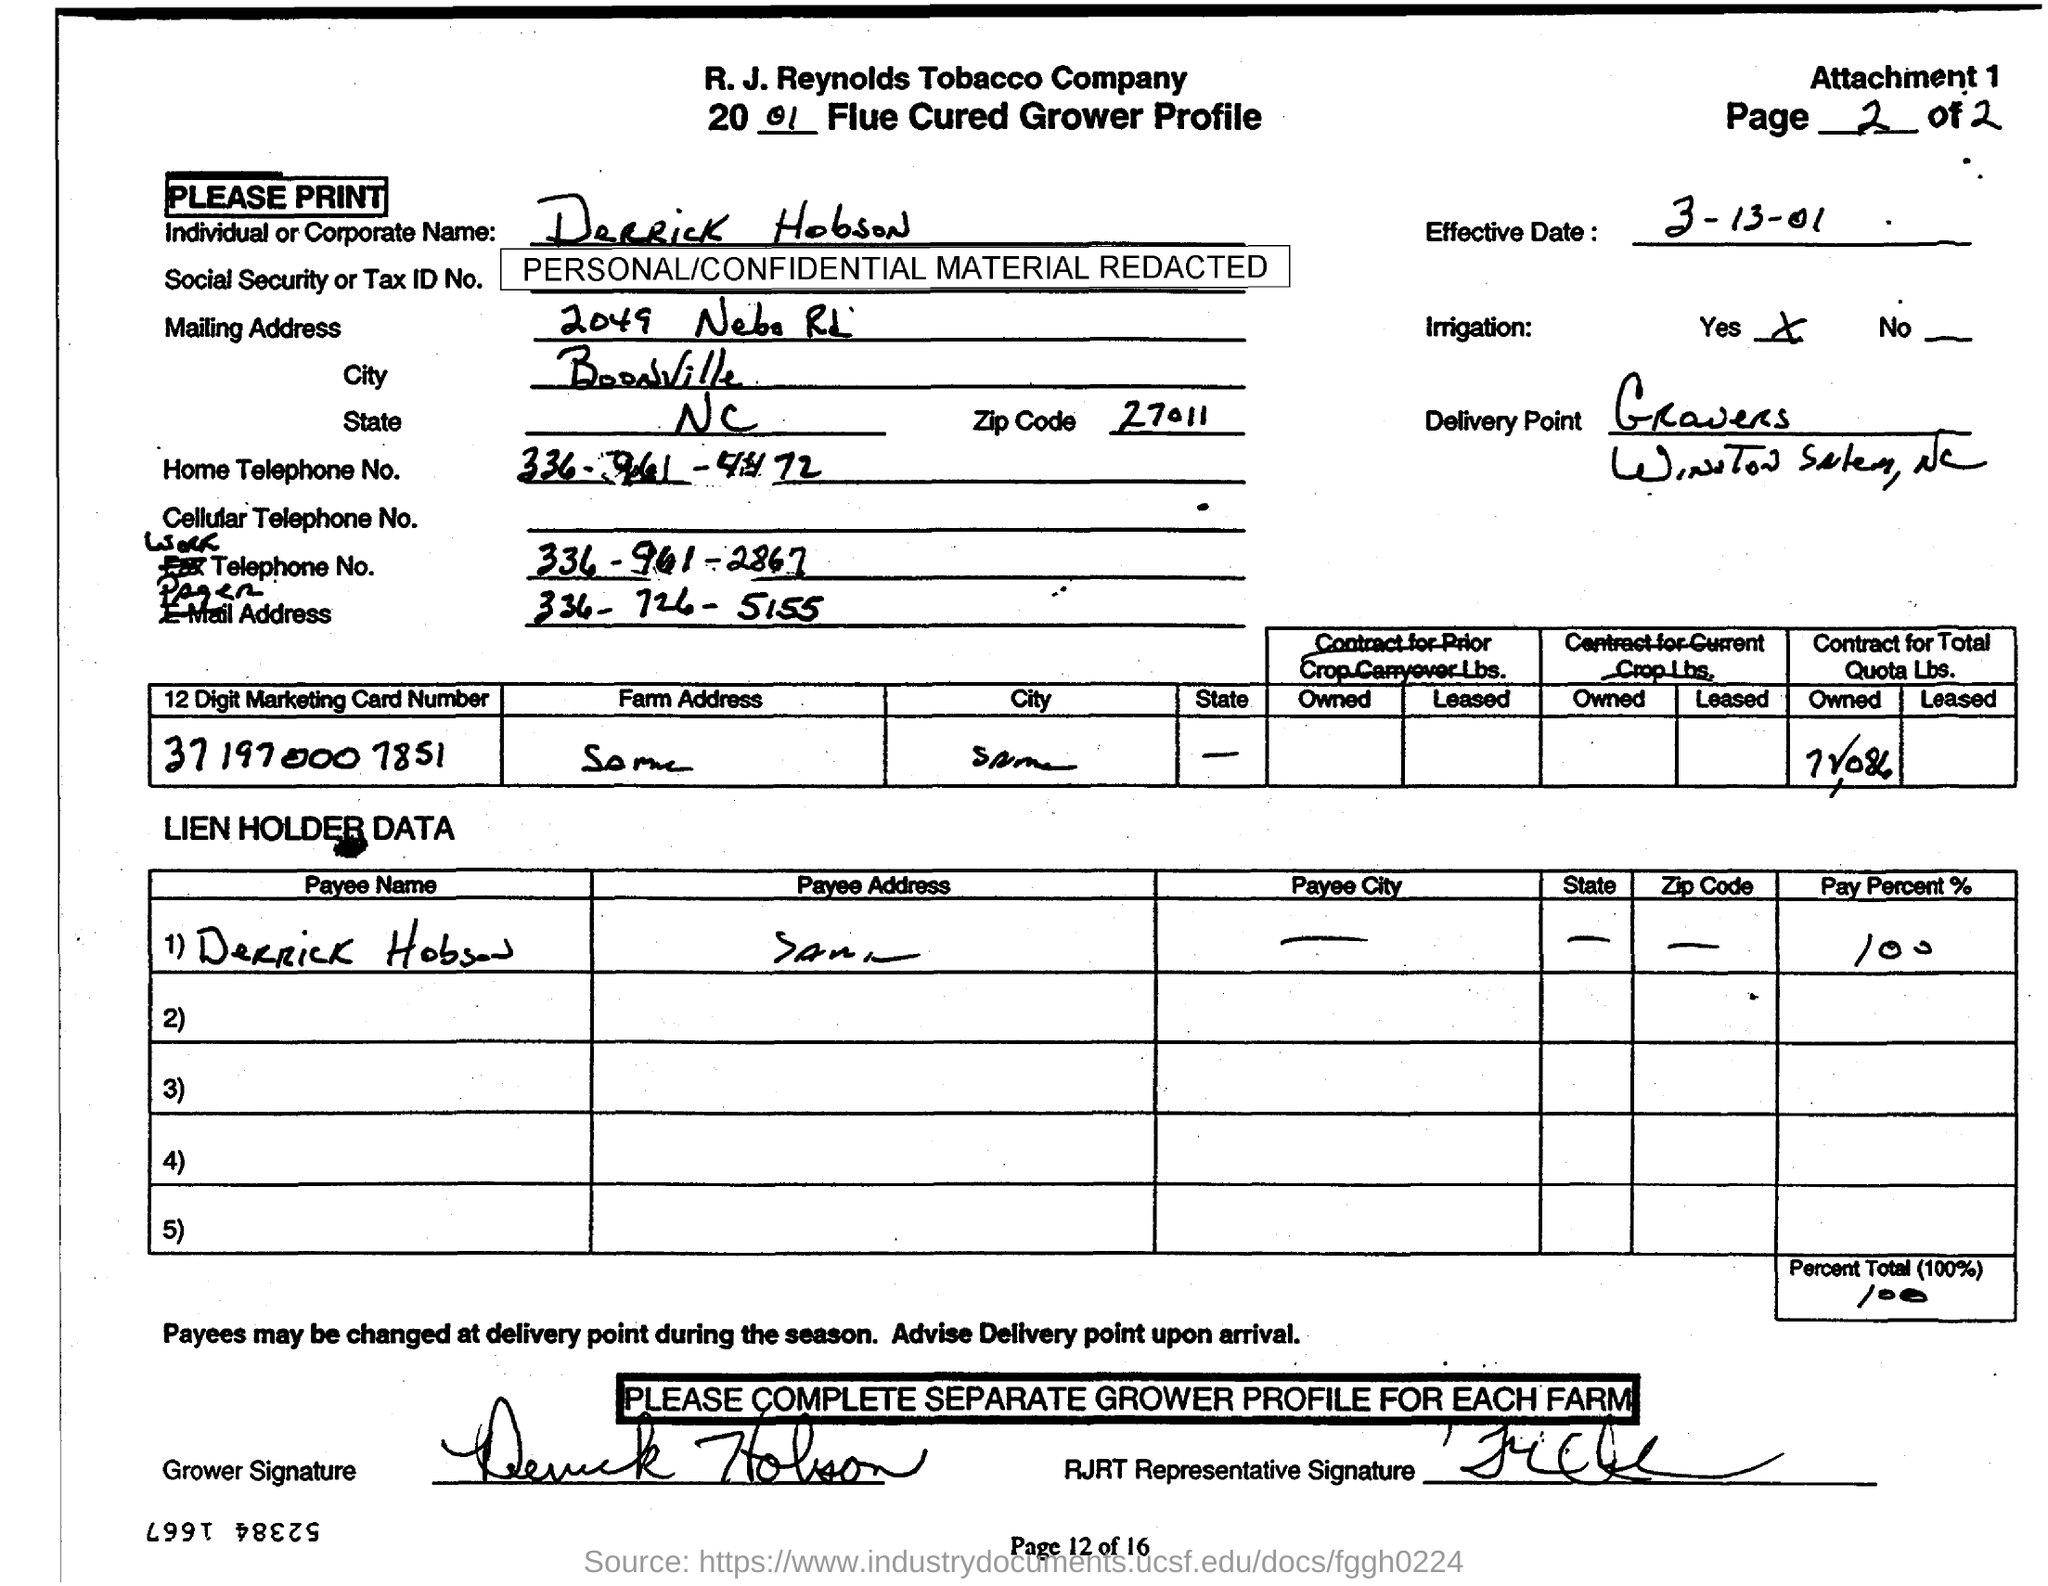What is the name of the Individual or Corporate ?
Offer a terse response. Derrick Hobson. What is the Effective Date mentioned?
Offer a terse response. 3-13-01. What is the City mentioned in the Mailing Address?
Offer a very short reply. Boonville. To which year does this document belong?
Offer a terse response. 2001. 